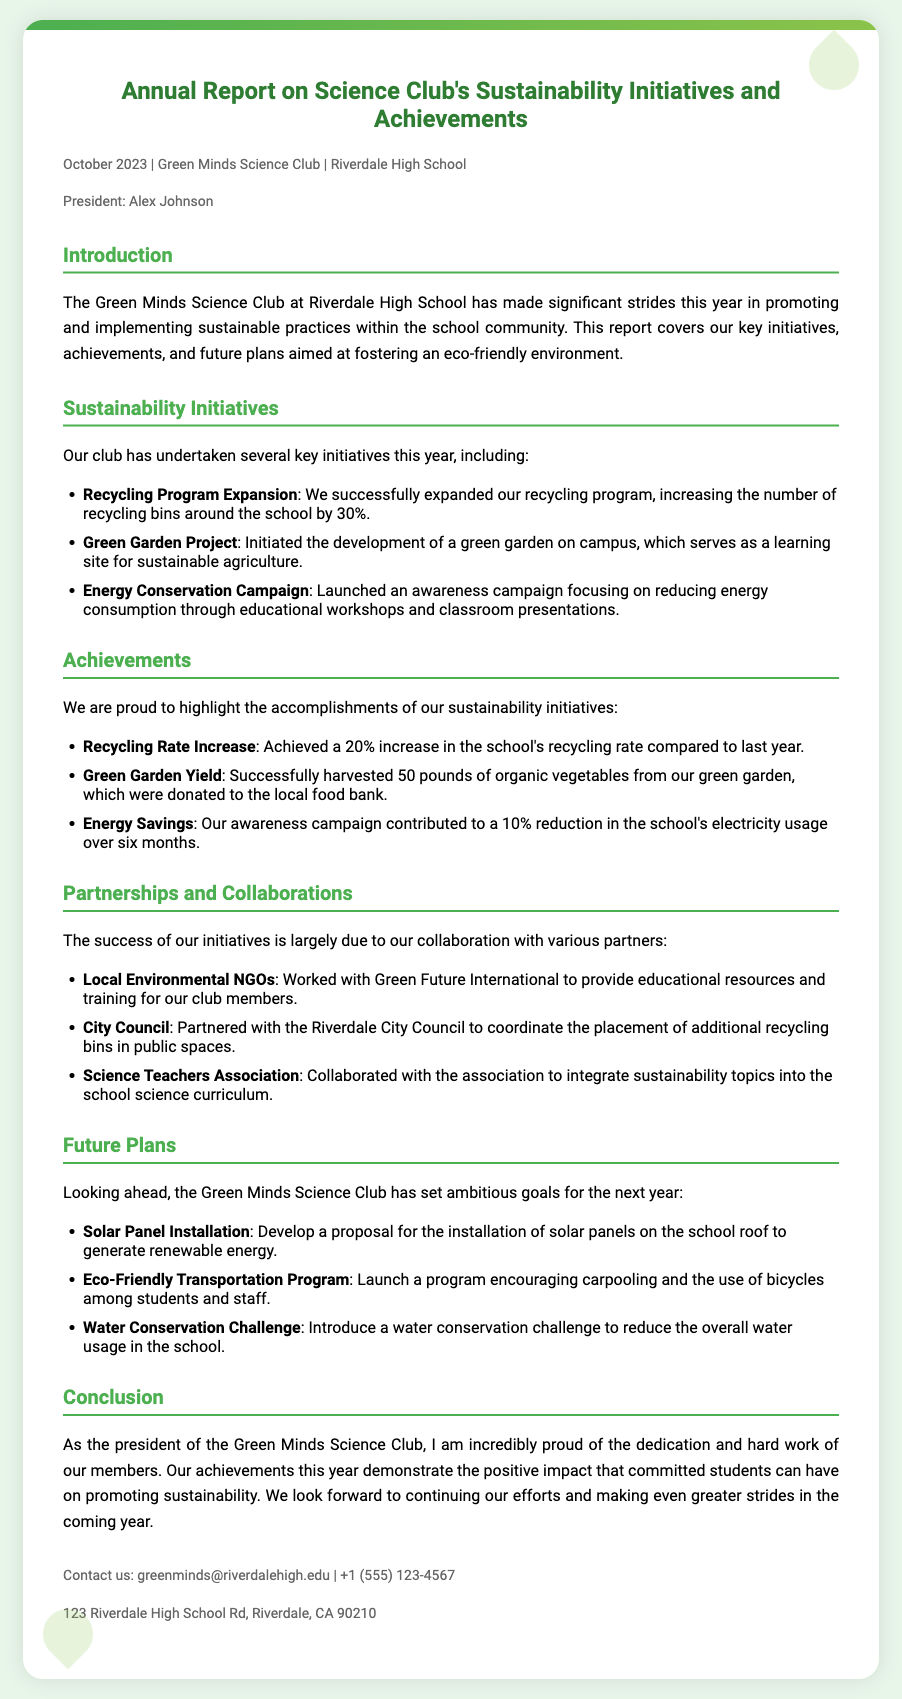What is the title of the report? The title of the report is stated at the top of the document, clearly indicating its content.
Answer: Annual Report on Science Club's Sustainability Initiatives and Achievements Who is the president of the Green Minds Science Club? The president's name is mentioned in the metadata section of the report.
Answer: Alex Johnson What percentage increase was achieved in the school's recycling rate? The report highlights a specific achievement related to recycling, providing a clear numerical increase.
Answer: 20% How many pounds of organic vegetables were harvested from the green garden? This information is provided in the achievements section regarding the green garden project.
Answer: 50 pounds Which environmental NGO did the club collaborate with? The report lists the organizations that the club partnered with for their initiatives.
Answer: Green Future International What is one of the future plans for the Green Minds Science Club? The future plans section details specific initiatives the club aims to pursue next year.
Answer: Solar Panel Installation Which campaign focused on reducing energy consumption? The initiatives section contains information about campaigns aimed at raising awareness about energy conservation.
Answer: Energy Conservation Campaign How many recycling bins were increased in the school? The document provides the specific numerical increase of recycling bins as part of the club's initiatives.
Answer: 30% 